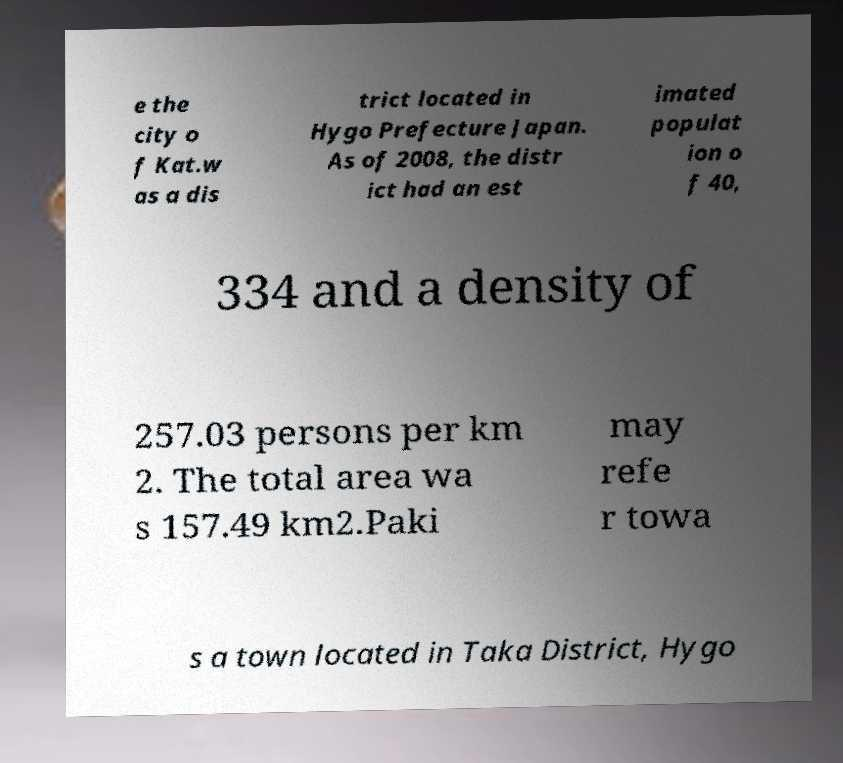Please identify and transcribe the text found in this image. e the city o f Kat.w as a dis trict located in Hygo Prefecture Japan. As of 2008, the distr ict had an est imated populat ion o f 40, 334 and a density of 257.03 persons per km 2. The total area wa s 157.49 km2.Paki may refe r towa s a town located in Taka District, Hygo 